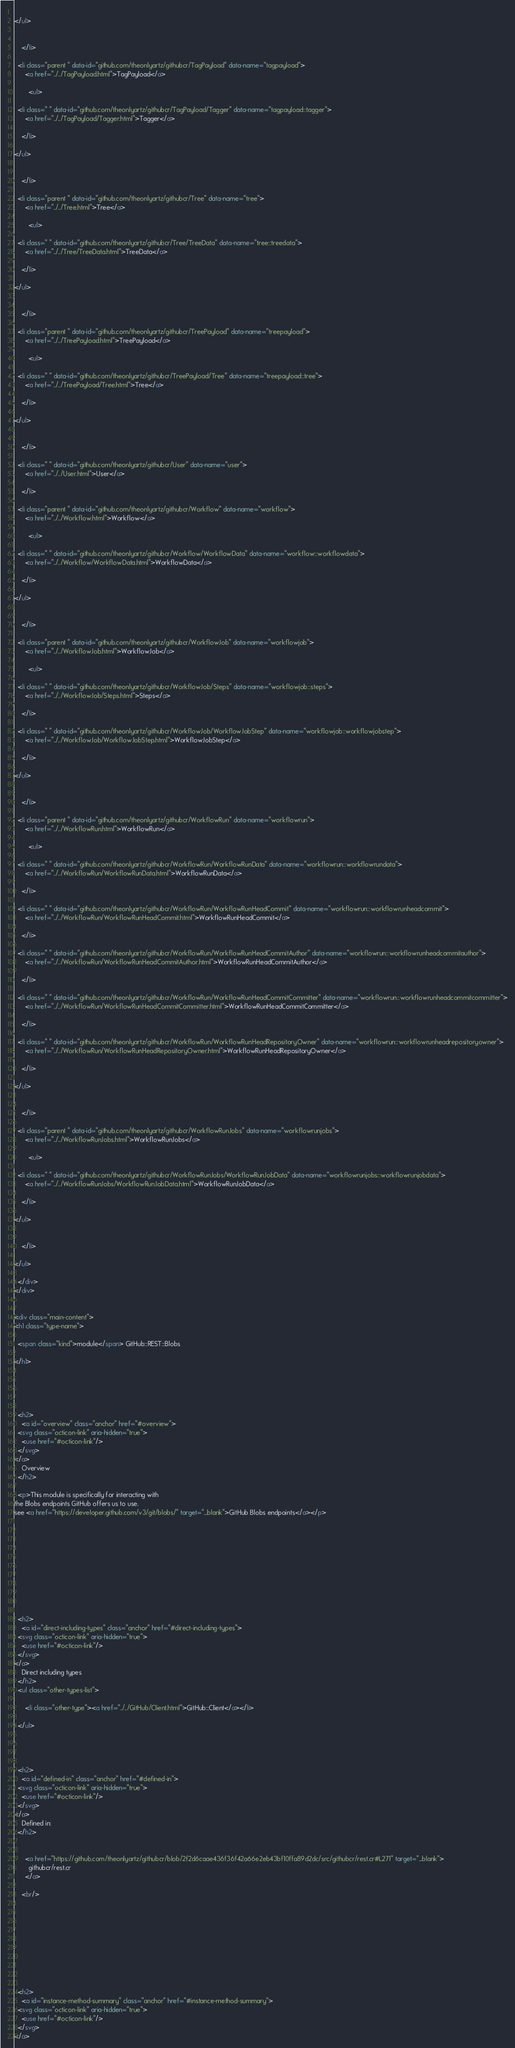<code> <loc_0><loc_0><loc_500><loc_500><_HTML_>  
</ul>

      
    </li>
  
  <li class="parent " data-id="github.com/theonlyartz/githubcr/TagPayload" data-name="tagpayload">
      <a href="../../TagPayload.html">TagPayload</a>
      
        <ul>
  
  <li class=" " data-id="github.com/theonlyartz/githubcr/TagPayload/Tagger" data-name="tagpayload::tagger">
      <a href="../../TagPayload/Tagger.html">Tagger</a>
      
    </li>
  
</ul>

      
    </li>
  
  <li class="parent " data-id="github.com/theonlyartz/githubcr/Tree" data-name="tree">
      <a href="../../Tree.html">Tree</a>
      
        <ul>
  
  <li class=" " data-id="github.com/theonlyartz/githubcr/Tree/TreeData" data-name="tree::treedata">
      <a href="../../Tree/TreeData.html">TreeData</a>
      
    </li>
  
</ul>

      
    </li>
  
  <li class="parent " data-id="github.com/theonlyartz/githubcr/TreePayload" data-name="treepayload">
      <a href="../../TreePayload.html">TreePayload</a>
      
        <ul>
  
  <li class=" " data-id="github.com/theonlyartz/githubcr/TreePayload/Tree" data-name="treepayload::tree">
      <a href="../../TreePayload/Tree.html">Tree</a>
      
    </li>
  
</ul>

      
    </li>
  
  <li class=" " data-id="github.com/theonlyartz/githubcr/User" data-name="user">
      <a href="../../User.html">User</a>
      
    </li>
  
  <li class="parent " data-id="github.com/theonlyartz/githubcr/Workflow" data-name="workflow">
      <a href="../../Workflow.html">Workflow</a>
      
        <ul>
  
  <li class=" " data-id="github.com/theonlyartz/githubcr/Workflow/WorkflowData" data-name="workflow::workflowdata">
      <a href="../../Workflow/WorkflowData.html">WorkflowData</a>
      
    </li>
  
</ul>

      
    </li>
  
  <li class="parent " data-id="github.com/theonlyartz/githubcr/WorkflowJob" data-name="workflowjob">
      <a href="../../WorkflowJob.html">WorkflowJob</a>
      
        <ul>
  
  <li class=" " data-id="github.com/theonlyartz/githubcr/WorkflowJob/Steps" data-name="workflowjob::steps">
      <a href="../../WorkflowJob/Steps.html">Steps</a>
      
    </li>
  
  <li class=" " data-id="github.com/theonlyartz/githubcr/WorkflowJob/WorkflowJobStep" data-name="workflowjob::workflowjobstep">
      <a href="../../WorkflowJob/WorkflowJobStep.html">WorkflowJobStep</a>
      
    </li>
  
</ul>

      
    </li>
  
  <li class="parent " data-id="github.com/theonlyartz/githubcr/WorkflowRun" data-name="workflowrun">
      <a href="../../WorkflowRun.html">WorkflowRun</a>
      
        <ul>
  
  <li class=" " data-id="github.com/theonlyartz/githubcr/WorkflowRun/WorkflowRunData" data-name="workflowrun::workflowrundata">
      <a href="../../WorkflowRun/WorkflowRunData.html">WorkflowRunData</a>
      
    </li>
  
  <li class=" " data-id="github.com/theonlyartz/githubcr/WorkflowRun/WorkflowRunHeadCommit" data-name="workflowrun::workflowrunheadcommit">
      <a href="../../WorkflowRun/WorkflowRunHeadCommit.html">WorkflowRunHeadCommit</a>
      
    </li>
  
  <li class=" " data-id="github.com/theonlyartz/githubcr/WorkflowRun/WorkflowRunHeadCommitAuthor" data-name="workflowrun::workflowrunheadcommitauthor">
      <a href="../../WorkflowRun/WorkflowRunHeadCommitAuthor.html">WorkflowRunHeadCommitAuthor</a>
      
    </li>
  
  <li class=" " data-id="github.com/theonlyartz/githubcr/WorkflowRun/WorkflowRunHeadCommitCommitter" data-name="workflowrun::workflowrunheadcommitcommitter">
      <a href="../../WorkflowRun/WorkflowRunHeadCommitCommitter.html">WorkflowRunHeadCommitCommitter</a>
      
    </li>
  
  <li class=" " data-id="github.com/theonlyartz/githubcr/WorkflowRun/WorkflowRunHeadRepositoryOwner" data-name="workflowrun::workflowrunheadrepositoryowner">
      <a href="../../WorkflowRun/WorkflowRunHeadRepositoryOwner.html">WorkflowRunHeadRepositoryOwner</a>
      
    </li>
  
</ul>

      
    </li>
  
  <li class="parent " data-id="github.com/theonlyartz/githubcr/WorkflowRunJobs" data-name="workflowrunjobs">
      <a href="../../WorkflowRunJobs.html">WorkflowRunJobs</a>
      
        <ul>
  
  <li class=" " data-id="github.com/theonlyartz/githubcr/WorkflowRunJobs/WorkflowRunJobData" data-name="workflowrunjobs::workflowrunjobdata">
      <a href="../../WorkflowRunJobs/WorkflowRunJobData.html">WorkflowRunJobData</a>
      
    </li>
  
</ul>

      
    </li>
  
</ul>

  </div>
</div>


<div class="main-content">
<h1 class="type-name">

  <span class="kind">module</span> GitHub::REST::Blobs

</h1>





  <h2>
    <a id="overview" class="anchor" href="#overview">
  <svg class="octicon-link" aria-hidden="true">
    <use href="#octicon-link"/>
  </svg>
</a>
    Overview
  </h2>

  <p>This module is specifically for interacting with
the Blobs endpoints GitHub offers us to use.
see <a href="https://developer.github.com/v3/git/blobs/" target="_blank">GitHub Blobs endpoints</a></p>











  <h2>
    <a id="direct-including-types" class="anchor" href="#direct-including-types">
  <svg class="octicon-link" aria-hidden="true">
    <use href="#octicon-link"/>
  </svg>
</a>
    Direct including types
  </h2>
  <ul class="other-types-list">
    
      <li class="other-type"><a href="../../GitHub/Client.html">GitHub::Client</a></li>
    
  </ul>




  <h2>
    <a id="defined-in" class="anchor" href="#defined-in">
  <svg class="octicon-link" aria-hidden="true">
    <use href="#octicon-link"/>
  </svg>
</a>
    Defined in:
  </h2>
  
    
      <a href="https://github.com/theonlyartz/githubcr/blob/2f2d6caae436f36f42a66e2eb43bf10ffa89d2dc/src/githubcr/rest.cr#L271" target="_blank">
        githubcr/rest.cr
      </a>
    
    <br/>
  









  <h2>
    <a id="instance-method-summary" class="anchor" href="#instance-method-summary">
  <svg class="octicon-link" aria-hidden="true">
    <use href="#octicon-link"/>
  </svg>
</a></code> 